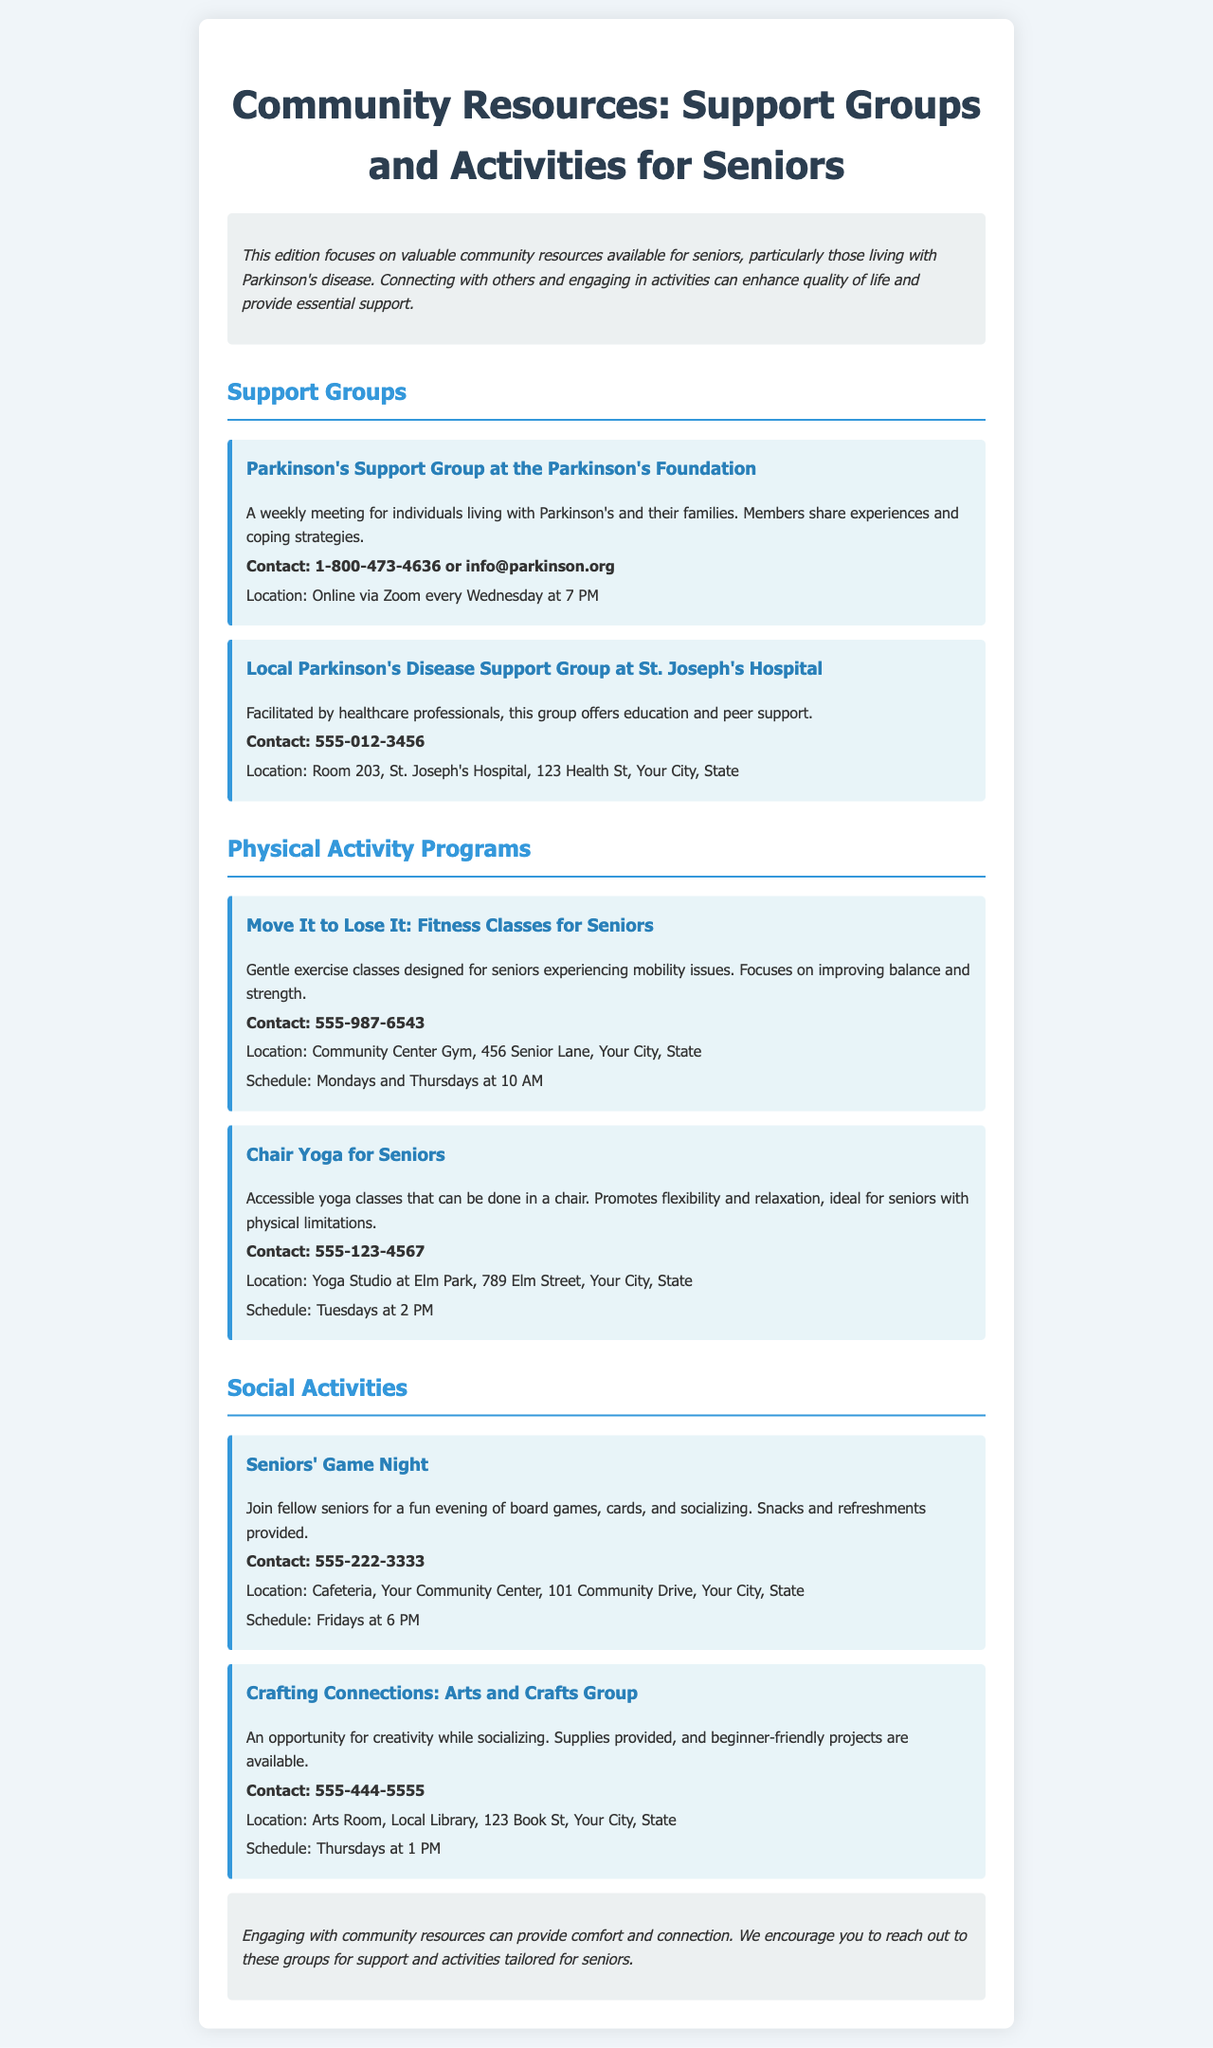What is the contact number for the Parkinson's Support Group? The contact number is clearly stated in the document for the Parkinson's Support Group at the Parkinson's Foundation.
Answer: 1-800-473-4636 What day and time does the Chair Yoga for Seniors class take place? The schedule for the Chair Yoga for Seniors is mentioned in the document, specifying the day and time.
Answer: Tuesdays at 2 PM Where is the Seniors' Game Night held? The location for the Seniors' Game Night is listed in the document under the social activities section.
Answer: Cafeteria, Your Community Center, 101 Community Drive, Your City, State What type of activities does the Crafting Connections group offer? The document describes the Crafting Connections group, indicating the nature of the activities offered.
Answer: Arts and Crafts What is the main purpose of support groups mentioned in the newsletter? The introductory part of the document explains the overall aim of support groups for seniors with Parkinson's disease.
Answer: Share experiences and coping strategies What physical activity program focuses on improving balance and strength? The document lists several physical activity programs, specifying which one targets balance and strength improvement.
Answer: Move It to Lose It: Fitness Classes for Seniors How often does the local Parkinson's Disease Support Group meet? The meeting frequency for the local Parkinson's Disease Support Group is provided in the document.
Answer: Weekly What kind of snacks are provided during the Seniors' Game Night? The document notes what is included in the event of the Seniors' Game Night.
Answer: Snacks and refreshments 